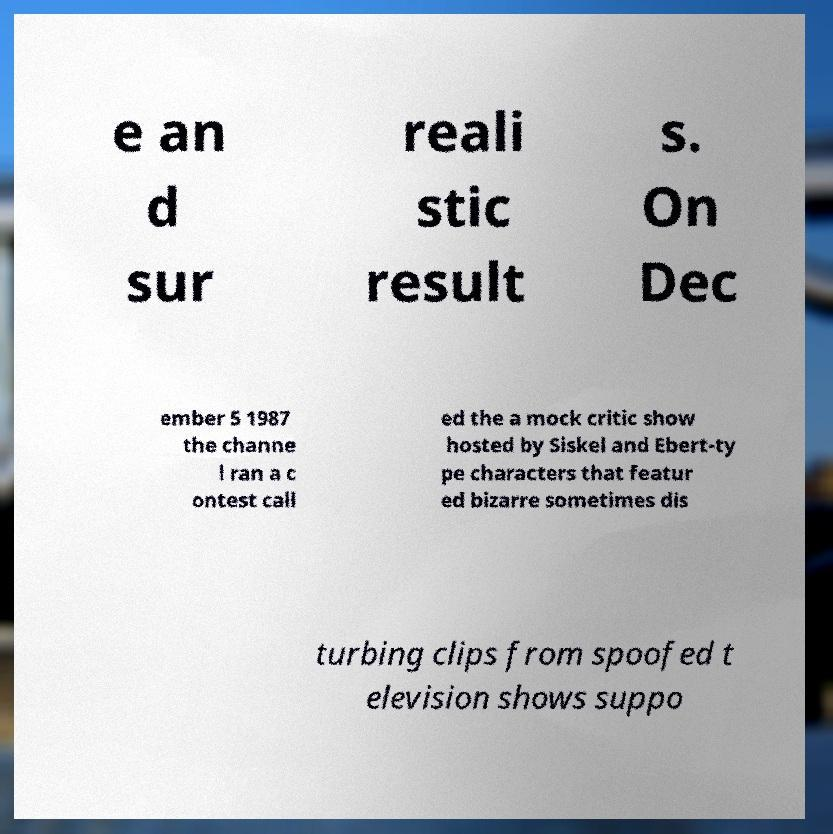There's text embedded in this image that I need extracted. Can you transcribe it verbatim? e an d sur reali stic result s. On Dec ember 5 1987 the channe l ran a c ontest call ed the a mock critic show hosted by Siskel and Ebert-ty pe characters that featur ed bizarre sometimes dis turbing clips from spoofed t elevision shows suppo 